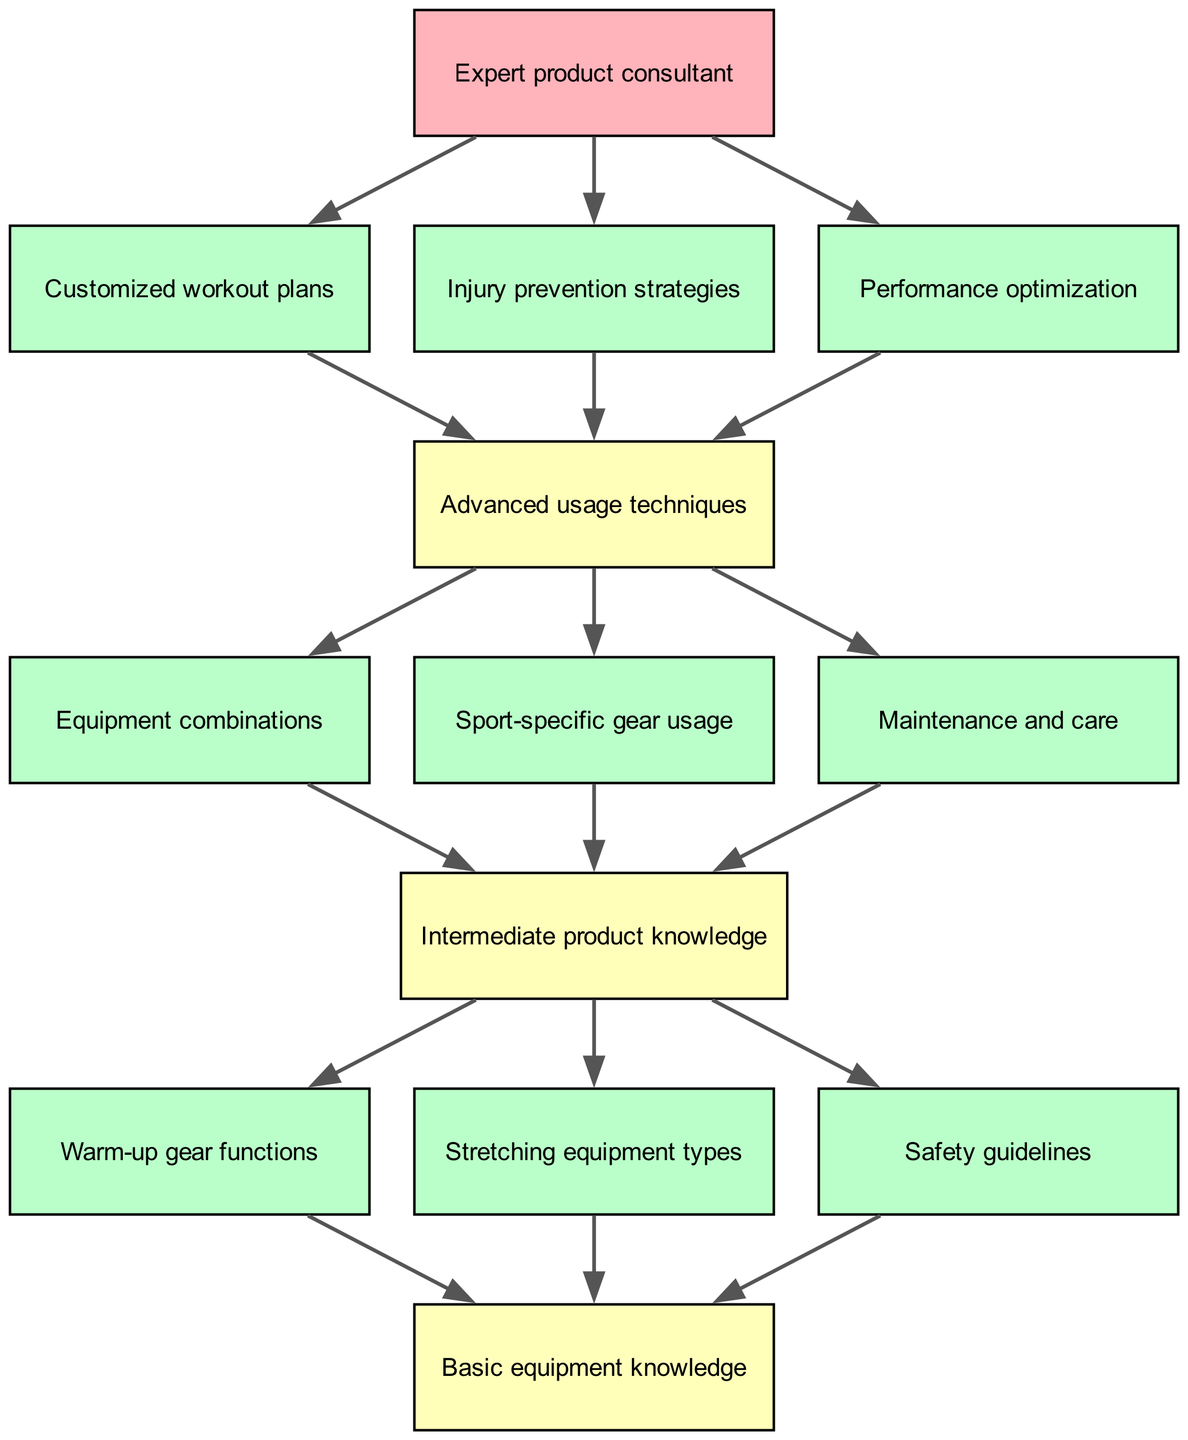What is the topmost node in the diagram? The topmost node is the one that does not have any parent; in this diagram, it is "Basic equipment knowledge".
Answer: Basic equipment knowledge How many nodes are there in total? By counting all the individual nodes provided in the diagram, including all levels, there are 13 nodes.
Answer: 13 What kind of knowledge does node 5 represent? Node 5 is labeled "Intermediate product knowledge," indicating a step beyond basic understanding.
Answer: Intermediate product knowledge Which node is a child of "Basic equipment knowledge"? The children of "Basic equipment knowledge" include nodes "Warm-up gear functions", "Stretching equipment types", and "Safety guidelines". Since the question is about any child, any of these would be correct, but one example is "Warm-up gear functions".
Answer: Warm-up gear functions What are the three types of advanced techniques listed in node 9? The three types of advanced techniques under "Advanced usage techniques" are "Customized workout plans", "Injury prevention strategies", and "Performance optimization".
Answer: Customized workout plans, Injury prevention strategies, Performance optimization How many child nodes does "Intermediate product knowledge" have? By examining node 5, we see that it has three children: "Equipment combinations," "Sport-specific gear usage," and "Maintenance and care," indicating it has three child nodes.
Answer: 3 What is the final step after achieving "Advanced usage techniques"? After reaching "Advanced usage techniques", the final step mentioned is "Expert product consultant", which suggests a culmination of training and expertise.
Answer: Expert product consultant How many layers are there in the training program structure? The diagram is structured into four layers, starting with "Basic equipment knowledge" at the top and evolving through intermediate aspects before reaching advanced techniques.
Answer: 4 What node represents safety guidelines? "Safety guidelines" is explicitly mentioned as one of the children of "Basic equipment knowledge" in the diagram.
Answer: Safety guidelines 